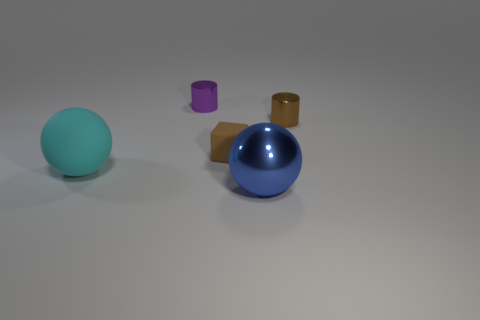Subtract all cubes. How many objects are left? 4 Subtract 1 blocks. How many blocks are left? 0 Subtract all yellow cylinders. Subtract all cyan balls. How many cylinders are left? 2 Subtract all gray cylinders. How many cyan spheres are left? 1 Subtract all brown cylinders. Subtract all brown blocks. How many objects are left? 3 Add 2 large rubber objects. How many large rubber objects are left? 3 Add 4 large things. How many large things exist? 6 Add 2 purple rubber spheres. How many objects exist? 7 Subtract all cyan spheres. How many spheres are left? 1 Subtract 0 purple spheres. How many objects are left? 5 